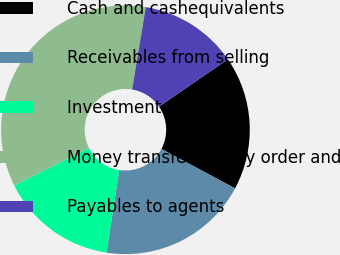Convert chart. <chart><loc_0><loc_0><loc_500><loc_500><pie_chart><fcel>Cash and cashequivalents<fcel>Receivables from selling<fcel>Investment securities<fcel>Money transfer money order and<fcel>Payables to agents<nl><fcel>17.4%<fcel>19.62%<fcel>15.17%<fcel>35.02%<fcel>12.79%<nl></chart> 